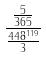<formula> <loc_0><loc_0><loc_500><loc_500>\frac { \frac { 5 } { 3 6 5 } } { \frac { 4 4 8 ^ { 1 1 9 } } { 3 } }</formula> 